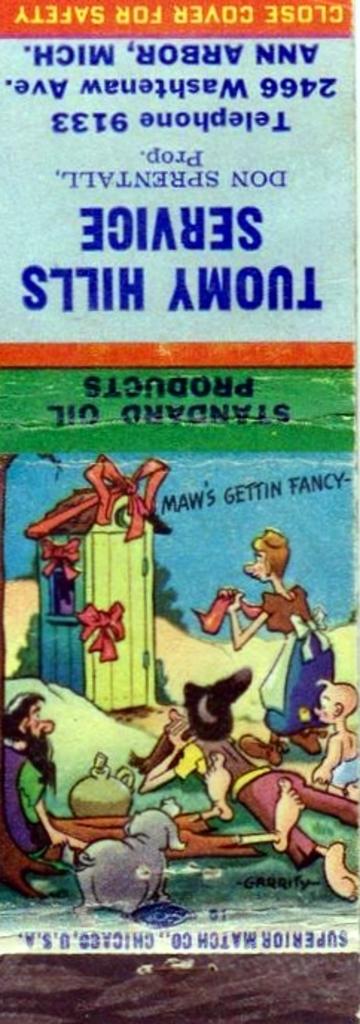What products are used here?
Offer a very short reply. Standard oil. What does it say to close the cover?
Offer a terse response. Safety. 